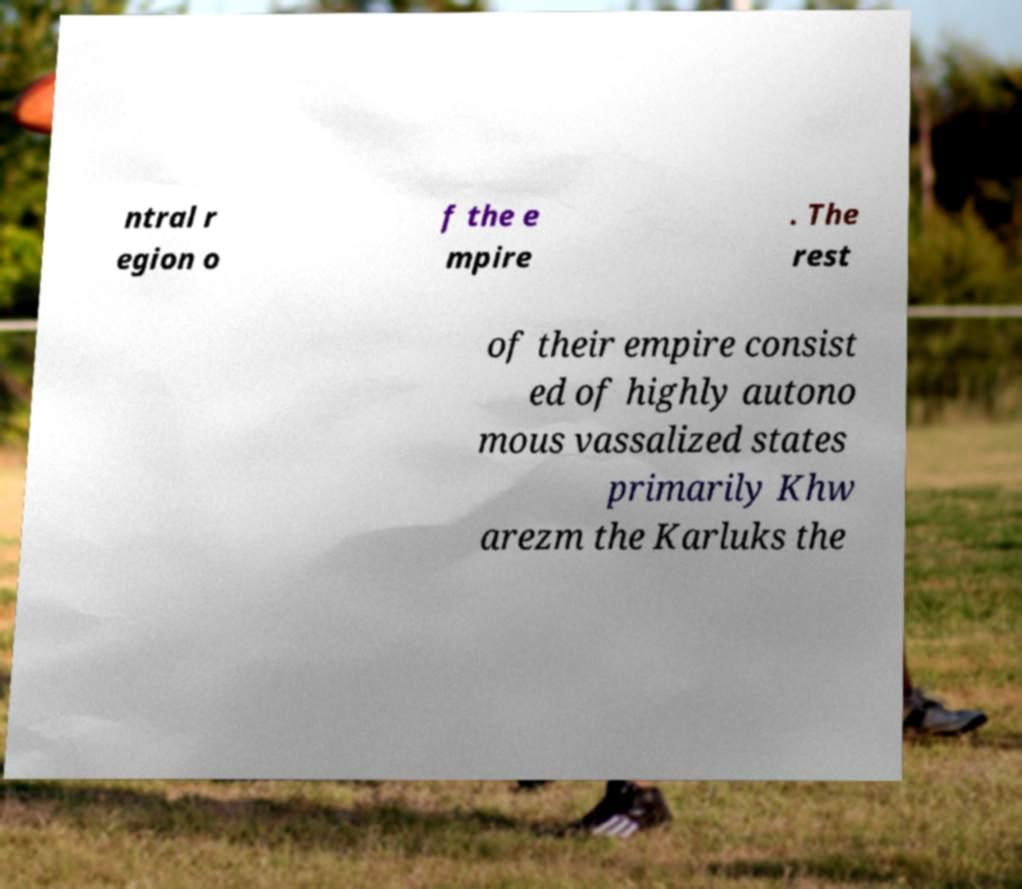Please identify and transcribe the text found in this image. ntral r egion o f the e mpire . The rest of their empire consist ed of highly autono mous vassalized states primarily Khw arezm the Karluks the 